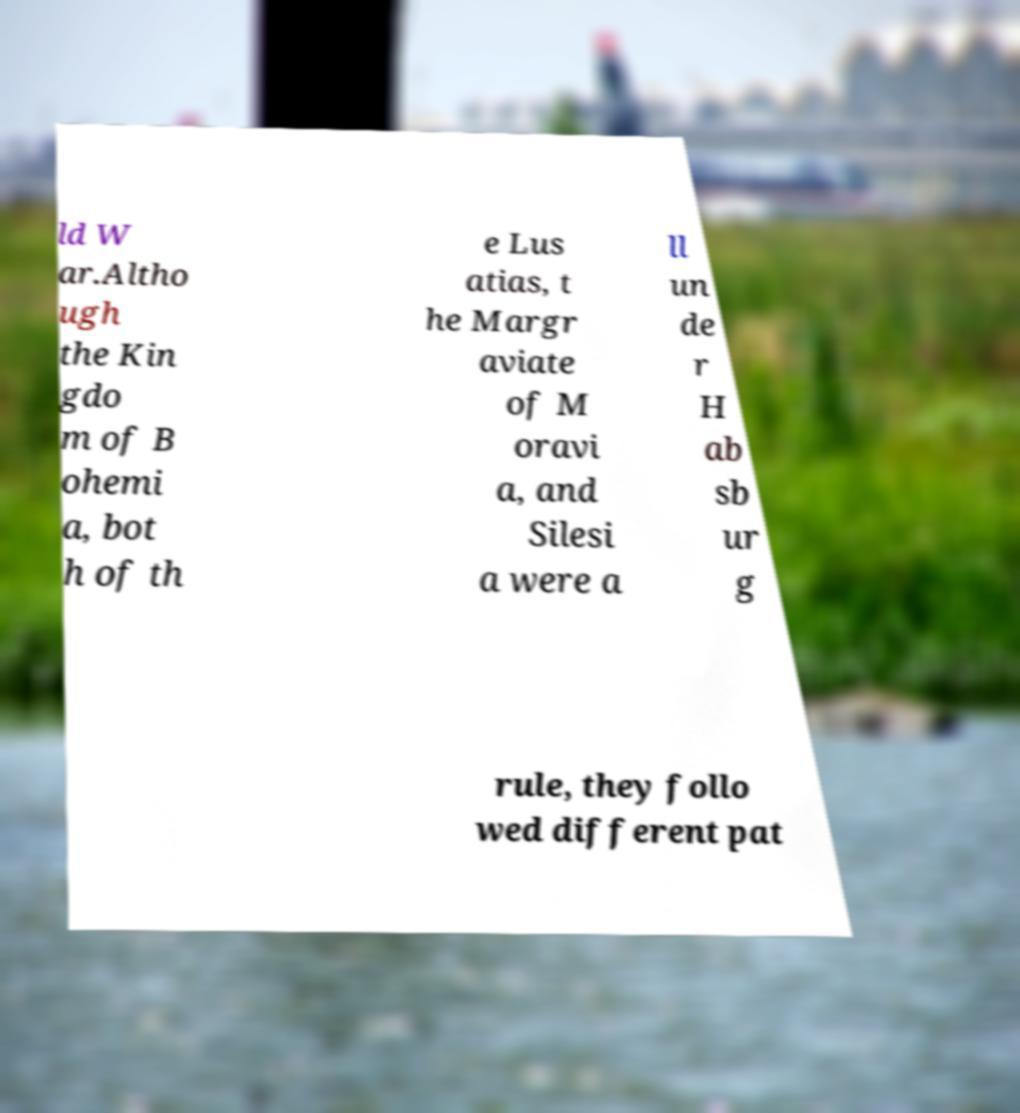There's text embedded in this image that I need extracted. Can you transcribe it verbatim? ld W ar.Altho ugh the Kin gdo m of B ohemi a, bot h of th e Lus atias, t he Margr aviate of M oravi a, and Silesi a were a ll un de r H ab sb ur g rule, they follo wed different pat 